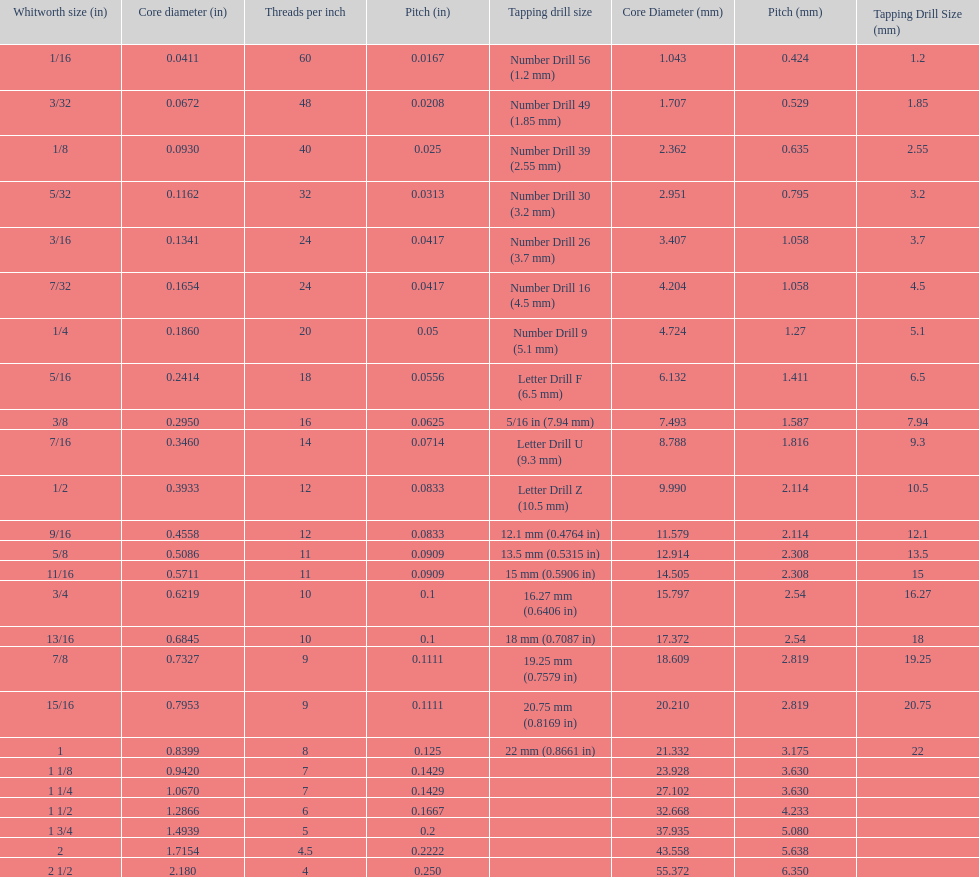Does any whitworth size have the same core diameter as the number drill 26? 3/16. 